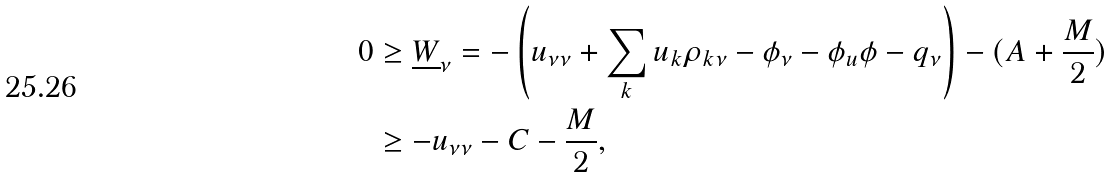Convert formula to latex. <formula><loc_0><loc_0><loc_500><loc_500>0 & \geq \underline { W } _ { \nu } = - \left ( u _ { \nu \nu } + \sum _ { k } u _ { k } \rho _ { k \nu } - \phi _ { \nu } - \phi _ { u } \phi - q _ { \nu } \right ) - ( A + \frac { M } { 2 } ) \\ & \geq - u _ { \nu \nu } - C - \frac { M } { 2 } ,</formula> 